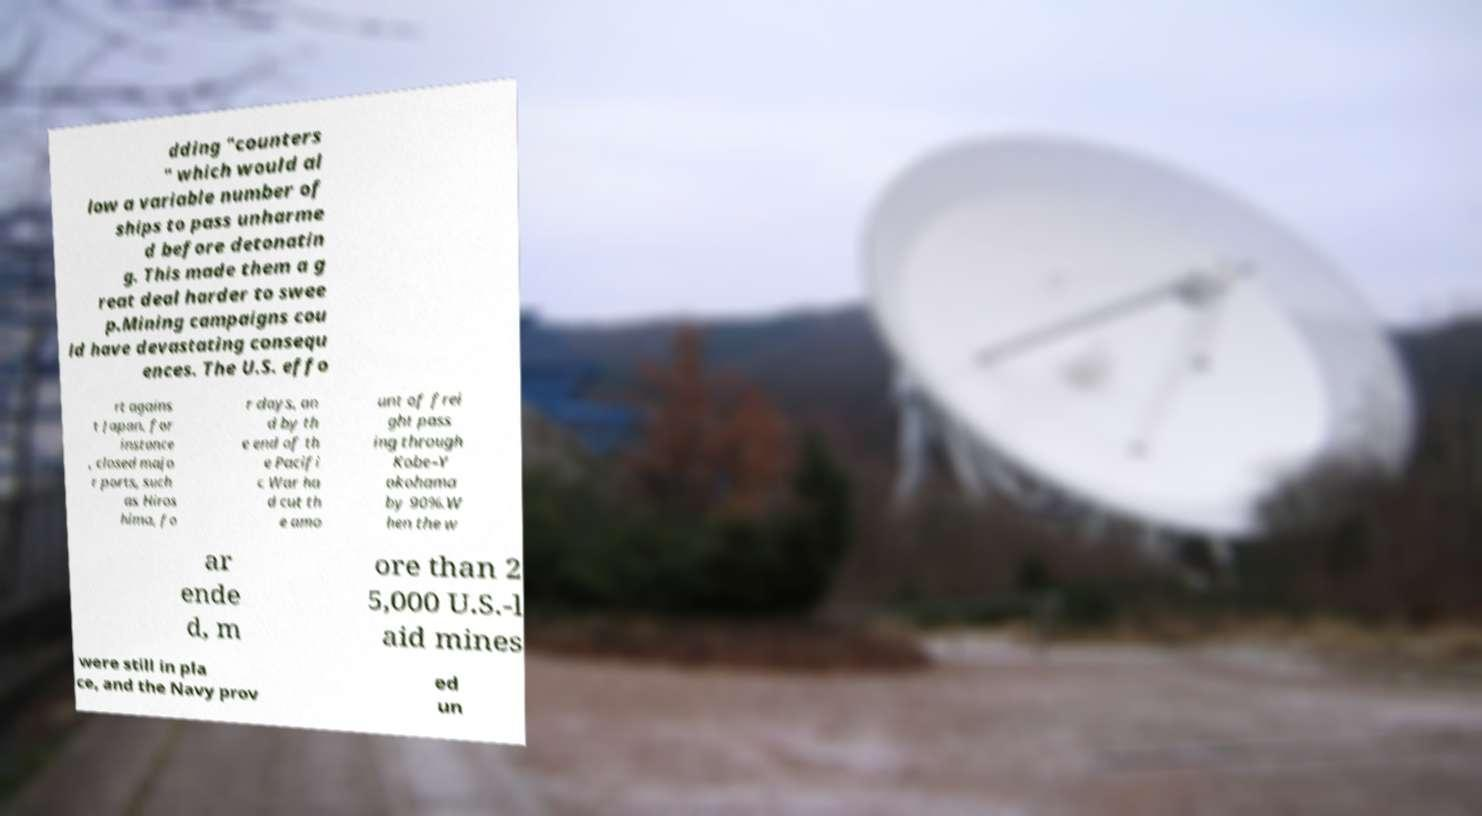Could you extract and type out the text from this image? dding "counters " which would al low a variable number of ships to pass unharme d before detonatin g. This made them a g reat deal harder to swee p.Mining campaigns cou ld have devastating consequ ences. The U.S. effo rt agains t Japan, for instance , closed majo r ports, such as Hiros hima, fo r days, an d by th e end of th e Pacifi c War ha d cut th e amo unt of frei ght pass ing through Kobe–Y okohama by 90%.W hen the w ar ende d, m ore than 2 5,000 U.S.-l aid mines were still in pla ce, and the Navy prov ed un 